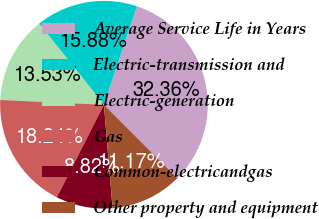<chart> <loc_0><loc_0><loc_500><loc_500><pie_chart><fcel>Average Service Life in Years<fcel>Electric-transmission and<fcel>Electric-generation<fcel>Gas<fcel>Common-electricandgas<fcel>Other property and equipment<nl><fcel>32.36%<fcel>15.88%<fcel>13.53%<fcel>18.24%<fcel>8.82%<fcel>11.17%<nl></chart> 